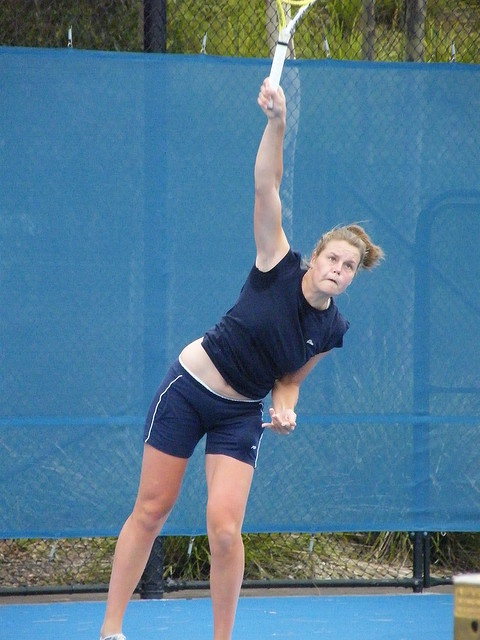Describe the objects in this image and their specific colors. I can see people in black, navy, lightpink, and darkgray tones and tennis racket in black, white, khaki, olive, and darkgray tones in this image. 